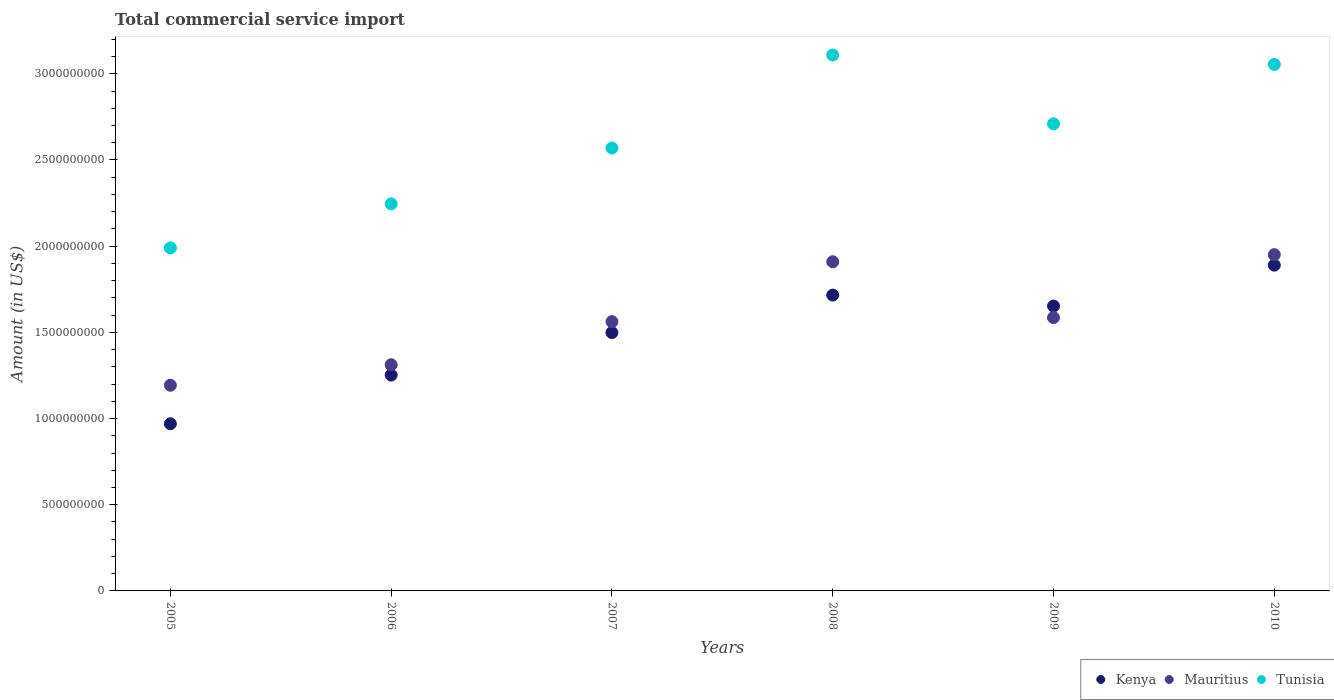Is the number of dotlines equal to the number of legend labels?
Make the answer very short. Yes. What is the total commercial service import in Kenya in 2007?
Your response must be concise. 1.50e+09. Across all years, what is the maximum total commercial service import in Mauritius?
Provide a succinct answer. 1.95e+09. Across all years, what is the minimum total commercial service import in Tunisia?
Ensure brevity in your answer.  1.99e+09. In which year was the total commercial service import in Mauritius maximum?
Give a very brief answer. 2010. In which year was the total commercial service import in Tunisia minimum?
Make the answer very short. 2005. What is the total total commercial service import in Kenya in the graph?
Provide a short and direct response. 8.98e+09. What is the difference between the total commercial service import in Mauritius in 2005 and that in 2007?
Make the answer very short. -3.69e+08. What is the difference between the total commercial service import in Kenya in 2009 and the total commercial service import in Tunisia in 2010?
Make the answer very short. -1.40e+09. What is the average total commercial service import in Mauritius per year?
Your response must be concise. 1.59e+09. In the year 2006, what is the difference between the total commercial service import in Mauritius and total commercial service import in Tunisia?
Make the answer very short. -9.33e+08. What is the ratio of the total commercial service import in Kenya in 2007 to that in 2010?
Ensure brevity in your answer.  0.79. What is the difference between the highest and the second highest total commercial service import in Mauritius?
Your response must be concise. 4.12e+07. What is the difference between the highest and the lowest total commercial service import in Tunisia?
Offer a terse response. 1.12e+09. In how many years, is the total commercial service import in Tunisia greater than the average total commercial service import in Tunisia taken over all years?
Provide a succinct answer. 3. Is the sum of the total commercial service import in Kenya in 2009 and 2010 greater than the maximum total commercial service import in Tunisia across all years?
Your answer should be very brief. Yes. Does the total commercial service import in Mauritius monotonically increase over the years?
Your answer should be very brief. No. Is the total commercial service import in Tunisia strictly greater than the total commercial service import in Kenya over the years?
Provide a succinct answer. Yes. How many years are there in the graph?
Offer a very short reply. 6. Are the values on the major ticks of Y-axis written in scientific E-notation?
Offer a terse response. No. Does the graph contain grids?
Your answer should be compact. No. How many legend labels are there?
Your answer should be compact. 3. What is the title of the graph?
Your answer should be very brief. Total commercial service import. Does "Malaysia" appear as one of the legend labels in the graph?
Your response must be concise. No. What is the Amount (in US$) in Kenya in 2005?
Your response must be concise. 9.70e+08. What is the Amount (in US$) in Mauritius in 2005?
Keep it short and to the point. 1.19e+09. What is the Amount (in US$) in Tunisia in 2005?
Give a very brief answer. 1.99e+09. What is the Amount (in US$) of Kenya in 2006?
Offer a very short reply. 1.25e+09. What is the Amount (in US$) in Mauritius in 2006?
Provide a short and direct response. 1.31e+09. What is the Amount (in US$) in Tunisia in 2006?
Provide a short and direct response. 2.25e+09. What is the Amount (in US$) in Kenya in 2007?
Your answer should be compact. 1.50e+09. What is the Amount (in US$) of Mauritius in 2007?
Keep it short and to the point. 1.56e+09. What is the Amount (in US$) of Tunisia in 2007?
Keep it short and to the point. 2.57e+09. What is the Amount (in US$) of Kenya in 2008?
Provide a succinct answer. 1.72e+09. What is the Amount (in US$) in Mauritius in 2008?
Offer a very short reply. 1.91e+09. What is the Amount (in US$) of Tunisia in 2008?
Offer a terse response. 3.11e+09. What is the Amount (in US$) of Kenya in 2009?
Offer a very short reply. 1.65e+09. What is the Amount (in US$) of Mauritius in 2009?
Ensure brevity in your answer.  1.59e+09. What is the Amount (in US$) of Tunisia in 2009?
Offer a terse response. 2.71e+09. What is the Amount (in US$) in Kenya in 2010?
Your answer should be compact. 1.89e+09. What is the Amount (in US$) in Mauritius in 2010?
Offer a terse response. 1.95e+09. What is the Amount (in US$) in Tunisia in 2010?
Your answer should be very brief. 3.05e+09. Across all years, what is the maximum Amount (in US$) of Kenya?
Give a very brief answer. 1.89e+09. Across all years, what is the maximum Amount (in US$) of Mauritius?
Your response must be concise. 1.95e+09. Across all years, what is the maximum Amount (in US$) of Tunisia?
Your response must be concise. 3.11e+09. Across all years, what is the minimum Amount (in US$) in Kenya?
Give a very brief answer. 9.70e+08. Across all years, what is the minimum Amount (in US$) in Mauritius?
Ensure brevity in your answer.  1.19e+09. Across all years, what is the minimum Amount (in US$) in Tunisia?
Offer a terse response. 1.99e+09. What is the total Amount (in US$) in Kenya in the graph?
Provide a short and direct response. 8.98e+09. What is the total Amount (in US$) in Mauritius in the graph?
Your answer should be very brief. 9.51e+09. What is the total Amount (in US$) in Tunisia in the graph?
Make the answer very short. 1.57e+1. What is the difference between the Amount (in US$) of Kenya in 2005 and that in 2006?
Keep it short and to the point. -2.82e+08. What is the difference between the Amount (in US$) of Mauritius in 2005 and that in 2006?
Provide a short and direct response. -1.19e+08. What is the difference between the Amount (in US$) in Tunisia in 2005 and that in 2006?
Your response must be concise. -2.55e+08. What is the difference between the Amount (in US$) of Kenya in 2005 and that in 2007?
Your answer should be very brief. -5.29e+08. What is the difference between the Amount (in US$) in Mauritius in 2005 and that in 2007?
Ensure brevity in your answer.  -3.69e+08. What is the difference between the Amount (in US$) of Tunisia in 2005 and that in 2007?
Provide a short and direct response. -5.79e+08. What is the difference between the Amount (in US$) in Kenya in 2005 and that in 2008?
Offer a very short reply. -7.47e+08. What is the difference between the Amount (in US$) in Mauritius in 2005 and that in 2008?
Your answer should be very brief. -7.17e+08. What is the difference between the Amount (in US$) in Tunisia in 2005 and that in 2008?
Your answer should be compact. -1.12e+09. What is the difference between the Amount (in US$) of Kenya in 2005 and that in 2009?
Your response must be concise. -6.83e+08. What is the difference between the Amount (in US$) of Mauritius in 2005 and that in 2009?
Provide a succinct answer. -3.93e+08. What is the difference between the Amount (in US$) in Tunisia in 2005 and that in 2009?
Provide a succinct answer. -7.20e+08. What is the difference between the Amount (in US$) of Kenya in 2005 and that in 2010?
Your answer should be compact. -9.20e+08. What is the difference between the Amount (in US$) of Mauritius in 2005 and that in 2010?
Give a very brief answer. -7.58e+08. What is the difference between the Amount (in US$) in Tunisia in 2005 and that in 2010?
Your answer should be compact. -1.06e+09. What is the difference between the Amount (in US$) in Kenya in 2006 and that in 2007?
Provide a succinct answer. -2.47e+08. What is the difference between the Amount (in US$) of Mauritius in 2006 and that in 2007?
Provide a succinct answer. -2.50e+08. What is the difference between the Amount (in US$) in Tunisia in 2006 and that in 2007?
Give a very brief answer. -3.24e+08. What is the difference between the Amount (in US$) in Kenya in 2006 and that in 2008?
Provide a succinct answer. -4.64e+08. What is the difference between the Amount (in US$) in Mauritius in 2006 and that in 2008?
Provide a short and direct response. -5.97e+08. What is the difference between the Amount (in US$) of Tunisia in 2006 and that in 2008?
Ensure brevity in your answer.  -8.64e+08. What is the difference between the Amount (in US$) in Kenya in 2006 and that in 2009?
Offer a terse response. -4.00e+08. What is the difference between the Amount (in US$) of Mauritius in 2006 and that in 2009?
Keep it short and to the point. -2.73e+08. What is the difference between the Amount (in US$) of Tunisia in 2006 and that in 2009?
Give a very brief answer. -4.65e+08. What is the difference between the Amount (in US$) of Kenya in 2006 and that in 2010?
Make the answer very short. -6.38e+08. What is the difference between the Amount (in US$) in Mauritius in 2006 and that in 2010?
Keep it short and to the point. -6.39e+08. What is the difference between the Amount (in US$) of Tunisia in 2006 and that in 2010?
Make the answer very short. -8.09e+08. What is the difference between the Amount (in US$) in Kenya in 2007 and that in 2008?
Offer a terse response. -2.18e+08. What is the difference between the Amount (in US$) in Mauritius in 2007 and that in 2008?
Your response must be concise. -3.47e+08. What is the difference between the Amount (in US$) of Tunisia in 2007 and that in 2008?
Offer a terse response. -5.40e+08. What is the difference between the Amount (in US$) in Kenya in 2007 and that in 2009?
Provide a succinct answer. -1.54e+08. What is the difference between the Amount (in US$) of Mauritius in 2007 and that in 2009?
Your response must be concise. -2.35e+07. What is the difference between the Amount (in US$) of Tunisia in 2007 and that in 2009?
Your answer should be very brief. -1.40e+08. What is the difference between the Amount (in US$) in Kenya in 2007 and that in 2010?
Offer a terse response. -3.91e+08. What is the difference between the Amount (in US$) of Mauritius in 2007 and that in 2010?
Offer a terse response. -3.89e+08. What is the difference between the Amount (in US$) in Tunisia in 2007 and that in 2010?
Ensure brevity in your answer.  -4.85e+08. What is the difference between the Amount (in US$) of Kenya in 2008 and that in 2009?
Provide a succinct answer. 6.37e+07. What is the difference between the Amount (in US$) of Mauritius in 2008 and that in 2009?
Offer a very short reply. 3.24e+08. What is the difference between the Amount (in US$) in Tunisia in 2008 and that in 2009?
Your response must be concise. 3.99e+08. What is the difference between the Amount (in US$) of Kenya in 2008 and that in 2010?
Make the answer very short. -1.74e+08. What is the difference between the Amount (in US$) in Mauritius in 2008 and that in 2010?
Ensure brevity in your answer.  -4.12e+07. What is the difference between the Amount (in US$) of Tunisia in 2008 and that in 2010?
Give a very brief answer. 5.46e+07. What is the difference between the Amount (in US$) of Kenya in 2009 and that in 2010?
Give a very brief answer. -2.37e+08. What is the difference between the Amount (in US$) in Mauritius in 2009 and that in 2010?
Your answer should be very brief. -3.65e+08. What is the difference between the Amount (in US$) in Tunisia in 2009 and that in 2010?
Give a very brief answer. -3.45e+08. What is the difference between the Amount (in US$) in Kenya in 2005 and the Amount (in US$) in Mauritius in 2006?
Give a very brief answer. -3.42e+08. What is the difference between the Amount (in US$) in Kenya in 2005 and the Amount (in US$) in Tunisia in 2006?
Your response must be concise. -1.28e+09. What is the difference between the Amount (in US$) in Mauritius in 2005 and the Amount (in US$) in Tunisia in 2006?
Your answer should be compact. -1.05e+09. What is the difference between the Amount (in US$) of Kenya in 2005 and the Amount (in US$) of Mauritius in 2007?
Keep it short and to the point. -5.92e+08. What is the difference between the Amount (in US$) of Kenya in 2005 and the Amount (in US$) of Tunisia in 2007?
Provide a succinct answer. -1.60e+09. What is the difference between the Amount (in US$) in Mauritius in 2005 and the Amount (in US$) in Tunisia in 2007?
Make the answer very short. -1.38e+09. What is the difference between the Amount (in US$) in Kenya in 2005 and the Amount (in US$) in Mauritius in 2008?
Make the answer very short. -9.40e+08. What is the difference between the Amount (in US$) in Kenya in 2005 and the Amount (in US$) in Tunisia in 2008?
Provide a succinct answer. -2.14e+09. What is the difference between the Amount (in US$) of Mauritius in 2005 and the Amount (in US$) of Tunisia in 2008?
Provide a short and direct response. -1.92e+09. What is the difference between the Amount (in US$) in Kenya in 2005 and the Amount (in US$) in Mauritius in 2009?
Provide a short and direct response. -6.16e+08. What is the difference between the Amount (in US$) of Kenya in 2005 and the Amount (in US$) of Tunisia in 2009?
Make the answer very short. -1.74e+09. What is the difference between the Amount (in US$) in Mauritius in 2005 and the Amount (in US$) in Tunisia in 2009?
Offer a very short reply. -1.52e+09. What is the difference between the Amount (in US$) of Kenya in 2005 and the Amount (in US$) of Mauritius in 2010?
Your answer should be compact. -9.81e+08. What is the difference between the Amount (in US$) of Kenya in 2005 and the Amount (in US$) of Tunisia in 2010?
Your answer should be compact. -2.08e+09. What is the difference between the Amount (in US$) of Mauritius in 2005 and the Amount (in US$) of Tunisia in 2010?
Make the answer very short. -1.86e+09. What is the difference between the Amount (in US$) of Kenya in 2006 and the Amount (in US$) of Mauritius in 2007?
Keep it short and to the point. -3.10e+08. What is the difference between the Amount (in US$) of Kenya in 2006 and the Amount (in US$) of Tunisia in 2007?
Your response must be concise. -1.32e+09. What is the difference between the Amount (in US$) in Mauritius in 2006 and the Amount (in US$) in Tunisia in 2007?
Give a very brief answer. -1.26e+09. What is the difference between the Amount (in US$) of Kenya in 2006 and the Amount (in US$) of Mauritius in 2008?
Provide a succinct answer. -6.57e+08. What is the difference between the Amount (in US$) of Kenya in 2006 and the Amount (in US$) of Tunisia in 2008?
Give a very brief answer. -1.86e+09. What is the difference between the Amount (in US$) of Mauritius in 2006 and the Amount (in US$) of Tunisia in 2008?
Ensure brevity in your answer.  -1.80e+09. What is the difference between the Amount (in US$) in Kenya in 2006 and the Amount (in US$) in Mauritius in 2009?
Offer a very short reply. -3.33e+08. What is the difference between the Amount (in US$) of Kenya in 2006 and the Amount (in US$) of Tunisia in 2009?
Your answer should be very brief. -1.46e+09. What is the difference between the Amount (in US$) in Mauritius in 2006 and the Amount (in US$) in Tunisia in 2009?
Make the answer very short. -1.40e+09. What is the difference between the Amount (in US$) in Kenya in 2006 and the Amount (in US$) in Mauritius in 2010?
Your answer should be very brief. -6.99e+08. What is the difference between the Amount (in US$) in Kenya in 2006 and the Amount (in US$) in Tunisia in 2010?
Give a very brief answer. -1.80e+09. What is the difference between the Amount (in US$) in Mauritius in 2006 and the Amount (in US$) in Tunisia in 2010?
Your response must be concise. -1.74e+09. What is the difference between the Amount (in US$) of Kenya in 2007 and the Amount (in US$) of Mauritius in 2008?
Provide a short and direct response. -4.11e+08. What is the difference between the Amount (in US$) in Kenya in 2007 and the Amount (in US$) in Tunisia in 2008?
Provide a short and direct response. -1.61e+09. What is the difference between the Amount (in US$) in Mauritius in 2007 and the Amount (in US$) in Tunisia in 2008?
Offer a terse response. -1.55e+09. What is the difference between the Amount (in US$) in Kenya in 2007 and the Amount (in US$) in Mauritius in 2009?
Keep it short and to the point. -8.68e+07. What is the difference between the Amount (in US$) in Kenya in 2007 and the Amount (in US$) in Tunisia in 2009?
Your response must be concise. -1.21e+09. What is the difference between the Amount (in US$) in Mauritius in 2007 and the Amount (in US$) in Tunisia in 2009?
Your answer should be compact. -1.15e+09. What is the difference between the Amount (in US$) in Kenya in 2007 and the Amount (in US$) in Mauritius in 2010?
Provide a succinct answer. -4.52e+08. What is the difference between the Amount (in US$) of Kenya in 2007 and the Amount (in US$) of Tunisia in 2010?
Your answer should be compact. -1.56e+09. What is the difference between the Amount (in US$) of Mauritius in 2007 and the Amount (in US$) of Tunisia in 2010?
Provide a succinct answer. -1.49e+09. What is the difference between the Amount (in US$) of Kenya in 2008 and the Amount (in US$) of Mauritius in 2009?
Make the answer very short. 1.31e+08. What is the difference between the Amount (in US$) in Kenya in 2008 and the Amount (in US$) in Tunisia in 2009?
Offer a terse response. -9.94e+08. What is the difference between the Amount (in US$) of Mauritius in 2008 and the Amount (in US$) of Tunisia in 2009?
Make the answer very short. -8.00e+08. What is the difference between the Amount (in US$) in Kenya in 2008 and the Amount (in US$) in Mauritius in 2010?
Provide a succinct answer. -2.34e+08. What is the difference between the Amount (in US$) in Kenya in 2008 and the Amount (in US$) in Tunisia in 2010?
Your response must be concise. -1.34e+09. What is the difference between the Amount (in US$) in Mauritius in 2008 and the Amount (in US$) in Tunisia in 2010?
Keep it short and to the point. -1.14e+09. What is the difference between the Amount (in US$) in Kenya in 2009 and the Amount (in US$) in Mauritius in 2010?
Give a very brief answer. -2.98e+08. What is the difference between the Amount (in US$) of Kenya in 2009 and the Amount (in US$) of Tunisia in 2010?
Keep it short and to the point. -1.40e+09. What is the difference between the Amount (in US$) of Mauritius in 2009 and the Amount (in US$) of Tunisia in 2010?
Provide a succinct answer. -1.47e+09. What is the average Amount (in US$) of Kenya per year?
Provide a succinct answer. 1.50e+09. What is the average Amount (in US$) of Mauritius per year?
Make the answer very short. 1.59e+09. What is the average Amount (in US$) of Tunisia per year?
Give a very brief answer. 2.61e+09. In the year 2005, what is the difference between the Amount (in US$) in Kenya and Amount (in US$) in Mauritius?
Give a very brief answer. -2.23e+08. In the year 2005, what is the difference between the Amount (in US$) of Kenya and Amount (in US$) of Tunisia?
Make the answer very short. -1.02e+09. In the year 2005, what is the difference between the Amount (in US$) in Mauritius and Amount (in US$) in Tunisia?
Offer a terse response. -7.97e+08. In the year 2006, what is the difference between the Amount (in US$) of Kenya and Amount (in US$) of Mauritius?
Keep it short and to the point. -6.00e+07. In the year 2006, what is the difference between the Amount (in US$) in Kenya and Amount (in US$) in Tunisia?
Keep it short and to the point. -9.93e+08. In the year 2006, what is the difference between the Amount (in US$) in Mauritius and Amount (in US$) in Tunisia?
Your response must be concise. -9.33e+08. In the year 2007, what is the difference between the Amount (in US$) of Kenya and Amount (in US$) of Mauritius?
Keep it short and to the point. -6.33e+07. In the year 2007, what is the difference between the Amount (in US$) of Kenya and Amount (in US$) of Tunisia?
Your answer should be compact. -1.07e+09. In the year 2007, what is the difference between the Amount (in US$) in Mauritius and Amount (in US$) in Tunisia?
Provide a short and direct response. -1.01e+09. In the year 2008, what is the difference between the Amount (in US$) of Kenya and Amount (in US$) of Mauritius?
Keep it short and to the point. -1.93e+08. In the year 2008, what is the difference between the Amount (in US$) of Kenya and Amount (in US$) of Tunisia?
Provide a short and direct response. -1.39e+09. In the year 2008, what is the difference between the Amount (in US$) of Mauritius and Amount (in US$) of Tunisia?
Your answer should be compact. -1.20e+09. In the year 2009, what is the difference between the Amount (in US$) of Kenya and Amount (in US$) of Mauritius?
Offer a very short reply. 6.69e+07. In the year 2009, what is the difference between the Amount (in US$) in Kenya and Amount (in US$) in Tunisia?
Your answer should be compact. -1.06e+09. In the year 2009, what is the difference between the Amount (in US$) of Mauritius and Amount (in US$) of Tunisia?
Give a very brief answer. -1.12e+09. In the year 2010, what is the difference between the Amount (in US$) of Kenya and Amount (in US$) of Mauritius?
Make the answer very short. -6.09e+07. In the year 2010, what is the difference between the Amount (in US$) of Kenya and Amount (in US$) of Tunisia?
Make the answer very short. -1.16e+09. In the year 2010, what is the difference between the Amount (in US$) of Mauritius and Amount (in US$) of Tunisia?
Ensure brevity in your answer.  -1.10e+09. What is the ratio of the Amount (in US$) in Kenya in 2005 to that in 2006?
Keep it short and to the point. 0.77. What is the ratio of the Amount (in US$) of Mauritius in 2005 to that in 2006?
Provide a succinct answer. 0.91. What is the ratio of the Amount (in US$) in Tunisia in 2005 to that in 2006?
Offer a terse response. 0.89. What is the ratio of the Amount (in US$) of Kenya in 2005 to that in 2007?
Offer a very short reply. 0.65. What is the ratio of the Amount (in US$) in Mauritius in 2005 to that in 2007?
Make the answer very short. 0.76. What is the ratio of the Amount (in US$) in Tunisia in 2005 to that in 2007?
Your response must be concise. 0.77. What is the ratio of the Amount (in US$) of Kenya in 2005 to that in 2008?
Your answer should be compact. 0.56. What is the ratio of the Amount (in US$) in Mauritius in 2005 to that in 2008?
Your response must be concise. 0.62. What is the ratio of the Amount (in US$) in Tunisia in 2005 to that in 2008?
Make the answer very short. 0.64. What is the ratio of the Amount (in US$) in Kenya in 2005 to that in 2009?
Your answer should be very brief. 0.59. What is the ratio of the Amount (in US$) in Mauritius in 2005 to that in 2009?
Your answer should be very brief. 0.75. What is the ratio of the Amount (in US$) in Tunisia in 2005 to that in 2009?
Your answer should be compact. 0.73. What is the ratio of the Amount (in US$) of Kenya in 2005 to that in 2010?
Your answer should be very brief. 0.51. What is the ratio of the Amount (in US$) of Mauritius in 2005 to that in 2010?
Provide a short and direct response. 0.61. What is the ratio of the Amount (in US$) in Tunisia in 2005 to that in 2010?
Offer a terse response. 0.65. What is the ratio of the Amount (in US$) in Kenya in 2006 to that in 2007?
Offer a terse response. 0.84. What is the ratio of the Amount (in US$) of Mauritius in 2006 to that in 2007?
Offer a very short reply. 0.84. What is the ratio of the Amount (in US$) in Tunisia in 2006 to that in 2007?
Give a very brief answer. 0.87. What is the ratio of the Amount (in US$) of Kenya in 2006 to that in 2008?
Offer a terse response. 0.73. What is the ratio of the Amount (in US$) of Mauritius in 2006 to that in 2008?
Provide a succinct answer. 0.69. What is the ratio of the Amount (in US$) in Tunisia in 2006 to that in 2008?
Keep it short and to the point. 0.72. What is the ratio of the Amount (in US$) of Kenya in 2006 to that in 2009?
Give a very brief answer. 0.76. What is the ratio of the Amount (in US$) in Mauritius in 2006 to that in 2009?
Provide a short and direct response. 0.83. What is the ratio of the Amount (in US$) of Tunisia in 2006 to that in 2009?
Your response must be concise. 0.83. What is the ratio of the Amount (in US$) of Kenya in 2006 to that in 2010?
Your answer should be very brief. 0.66. What is the ratio of the Amount (in US$) in Mauritius in 2006 to that in 2010?
Your response must be concise. 0.67. What is the ratio of the Amount (in US$) of Tunisia in 2006 to that in 2010?
Offer a very short reply. 0.74. What is the ratio of the Amount (in US$) in Kenya in 2007 to that in 2008?
Provide a succinct answer. 0.87. What is the ratio of the Amount (in US$) in Mauritius in 2007 to that in 2008?
Ensure brevity in your answer.  0.82. What is the ratio of the Amount (in US$) in Tunisia in 2007 to that in 2008?
Your response must be concise. 0.83. What is the ratio of the Amount (in US$) of Kenya in 2007 to that in 2009?
Your answer should be very brief. 0.91. What is the ratio of the Amount (in US$) in Mauritius in 2007 to that in 2009?
Provide a succinct answer. 0.99. What is the ratio of the Amount (in US$) of Tunisia in 2007 to that in 2009?
Provide a succinct answer. 0.95. What is the ratio of the Amount (in US$) of Kenya in 2007 to that in 2010?
Provide a short and direct response. 0.79. What is the ratio of the Amount (in US$) of Mauritius in 2007 to that in 2010?
Offer a very short reply. 0.8. What is the ratio of the Amount (in US$) of Tunisia in 2007 to that in 2010?
Your response must be concise. 0.84. What is the ratio of the Amount (in US$) in Kenya in 2008 to that in 2009?
Ensure brevity in your answer.  1.04. What is the ratio of the Amount (in US$) of Mauritius in 2008 to that in 2009?
Keep it short and to the point. 1.2. What is the ratio of the Amount (in US$) of Tunisia in 2008 to that in 2009?
Make the answer very short. 1.15. What is the ratio of the Amount (in US$) in Kenya in 2008 to that in 2010?
Give a very brief answer. 0.91. What is the ratio of the Amount (in US$) of Mauritius in 2008 to that in 2010?
Your answer should be very brief. 0.98. What is the ratio of the Amount (in US$) in Tunisia in 2008 to that in 2010?
Ensure brevity in your answer.  1.02. What is the ratio of the Amount (in US$) in Kenya in 2009 to that in 2010?
Keep it short and to the point. 0.87. What is the ratio of the Amount (in US$) of Mauritius in 2009 to that in 2010?
Ensure brevity in your answer.  0.81. What is the ratio of the Amount (in US$) in Tunisia in 2009 to that in 2010?
Your response must be concise. 0.89. What is the difference between the highest and the second highest Amount (in US$) of Kenya?
Your answer should be very brief. 1.74e+08. What is the difference between the highest and the second highest Amount (in US$) in Mauritius?
Provide a short and direct response. 4.12e+07. What is the difference between the highest and the second highest Amount (in US$) in Tunisia?
Offer a very short reply. 5.46e+07. What is the difference between the highest and the lowest Amount (in US$) of Kenya?
Your response must be concise. 9.20e+08. What is the difference between the highest and the lowest Amount (in US$) in Mauritius?
Provide a succinct answer. 7.58e+08. What is the difference between the highest and the lowest Amount (in US$) in Tunisia?
Make the answer very short. 1.12e+09. 